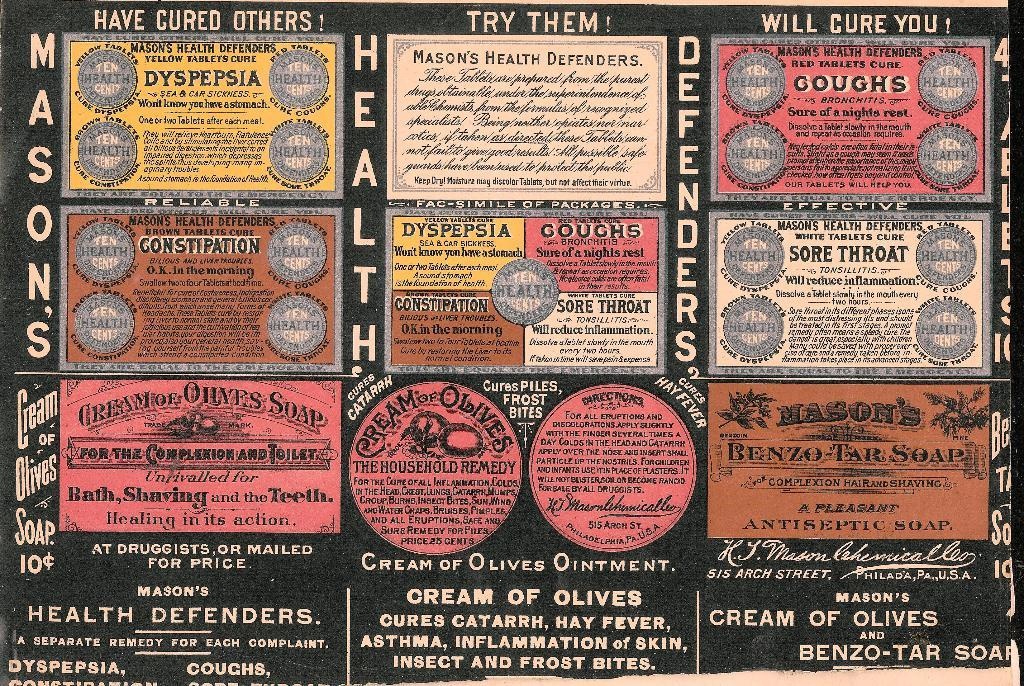Provide a one-sentence caption for the provided image. a page that says 'mason's health defenders' on it. 